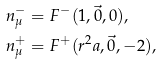Convert formula to latex. <formula><loc_0><loc_0><loc_500><loc_500>n ^ { - } _ { \mu } & = F ^ { - } ( 1 , \vec { 0 } , 0 ) , \\ n ^ { + } _ { \mu } & = F ^ { + } ( r ^ { 2 } a , \vec { 0 } , - 2 ) ,</formula> 